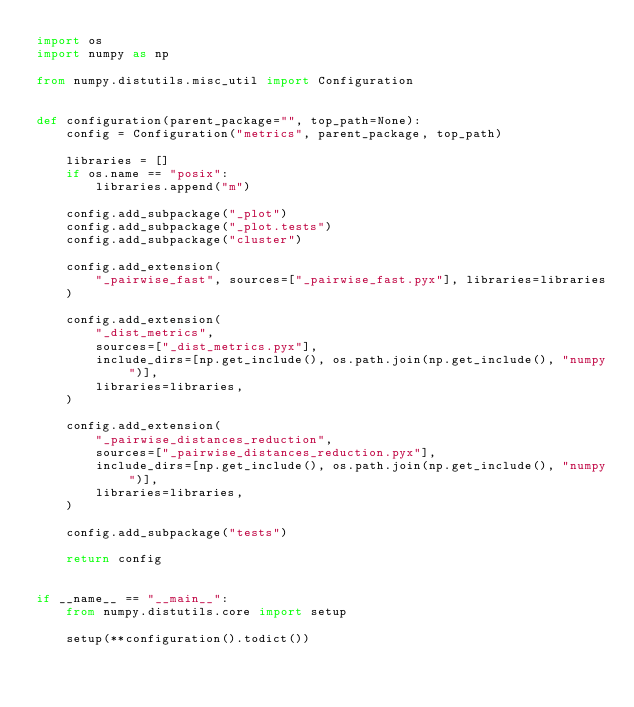<code> <loc_0><loc_0><loc_500><loc_500><_Python_>import os
import numpy as np

from numpy.distutils.misc_util import Configuration


def configuration(parent_package="", top_path=None):
    config = Configuration("metrics", parent_package, top_path)

    libraries = []
    if os.name == "posix":
        libraries.append("m")

    config.add_subpackage("_plot")
    config.add_subpackage("_plot.tests")
    config.add_subpackage("cluster")

    config.add_extension(
        "_pairwise_fast", sources=["_pairwise_fast.pyx"], libraries=libraries
    )

    config.add_extension(
        "_dist_metrics",
        sources=["_dist_metrics.pyx"],
        include_dirs=[np.get_include(), os.path.join(np.get_include(), "numpy")],
        libraries=libraries,
    )

    config.add_extension(
        "_pairwise_distances_reduction",
        sources=["_pairwise_distances_reduction.pyx"],
        include_dirs=[np.get_include(), os.path.join(np.get_include(), "numpy")],
        libraries=libraries,
    )

    config.add_subpackage("tests")

    return config


if __name__ == "__main__":
    from numpy.distutils.core import setup

    setup(**configuration().todict())
</code> 